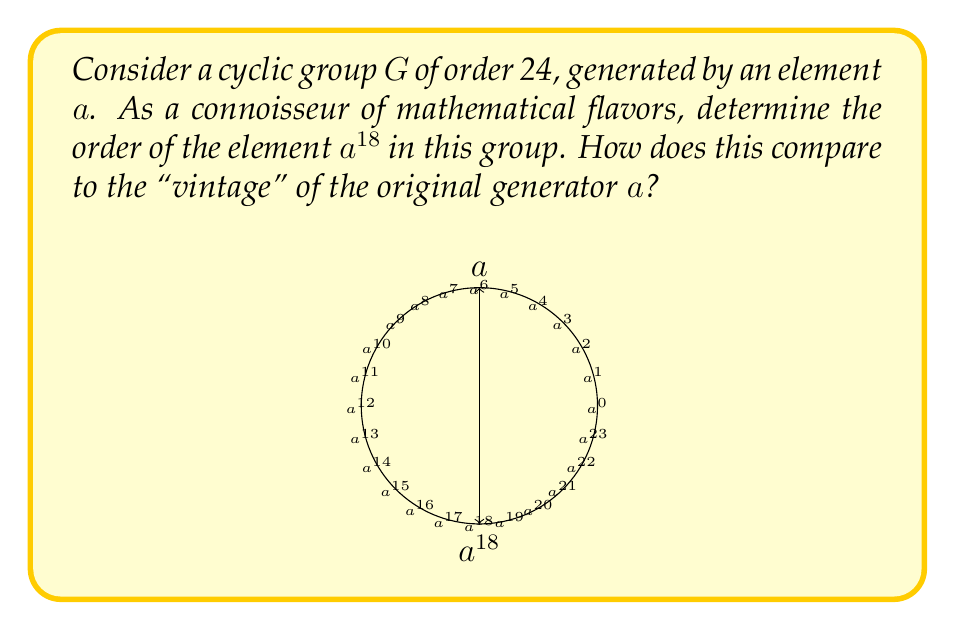Solve this math problem. Let's approach this problem step-by-step, savoring each mathematical nuance:

1) First, recall that in a cyclic group of order $n$, the order of an element $a^k$ is given by:

   $$\text{ord}(a^k) = \frac{n}{\gcd(n,k)}$$

   where $\gcd$ stands for the greatest common divisor.

2) In our case, $n = 24$ (the order of the group) and $k = 18$ (the power of $a$ we're examining).

3) Let's calculate the $\gcd(24,18)$:
   
   24 = 1 × 18 + 6
   18 = 3 × 6 + 0

   Therefore, $\gcd(24,18) = 6$

4) Now we can apply our formula:

   $$\text{ord}(a^{18}) = \frac{24}{\gcd(24,18)} = \frac{24}{6} = 4$$

5) Interpreting this result: While the original "vintage" element $a$ generates the entire group of order 24, our $a^{18}$ has a more refined, concentrated flavor, generating a subgroup of order 4.
Answer: $\text{ord}(a^{18}) = 4$ 